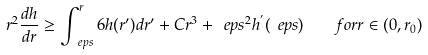<formula> <loc_0><loc_0><loc_500><loc_500>r ^ { 2 } \frac { d h } { d r } \geq \int _ { \ e p s } ^ { r } 6 h ( r ^ { \prime } ) d r ^ { \prime } + C r ^ { 3 } + \ e p s ^ { 2 } h ^ { ^ { \prime } } ( \ e p s ) \quad f o r r \in ( 0 , r _ { 0 } )</formula> 